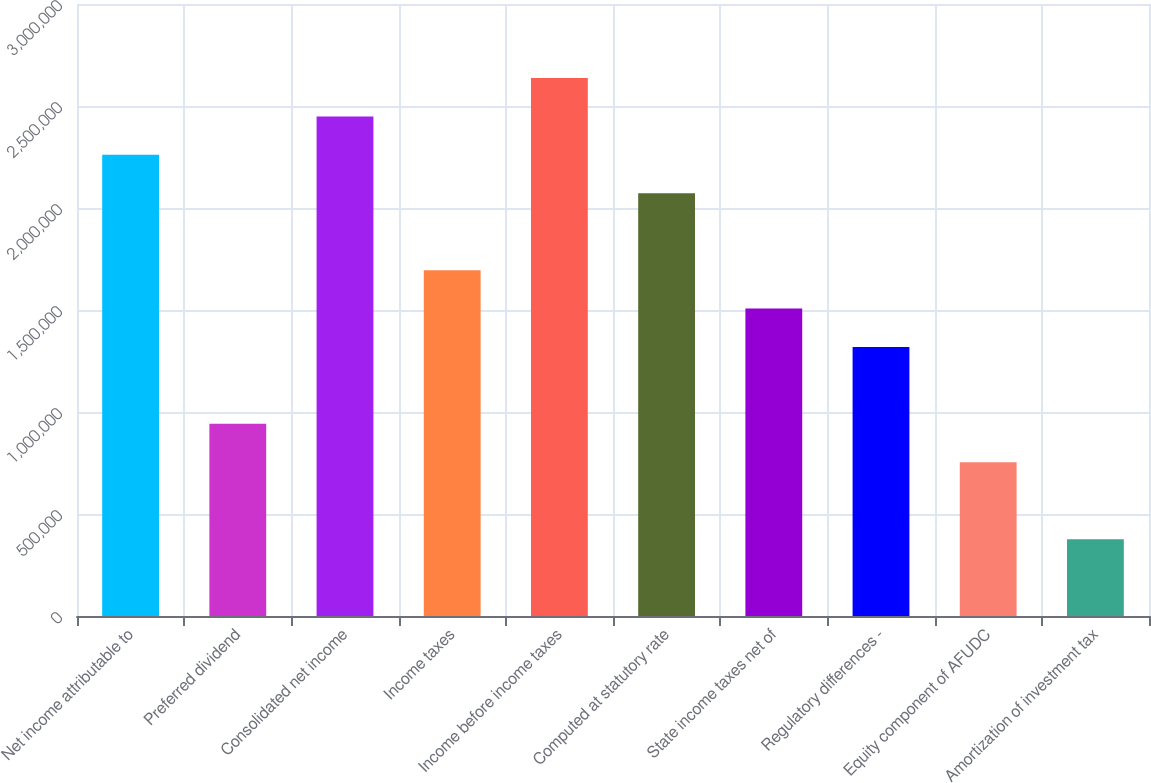Convert chart. <chart><loc_0><loc_0><loc_500><loc_500><bar_chart><fcel>Net income attributable to<fcel>Preferred dividend<fcel>Consolidated net income<fcel>Income taxes<fcel>Income before income taxes<fcel>Computed at statutory rate<fcel>State income taxes net of<fcel>Regulatory differences -<fcel>Equity component of AFUDC<fcel>Amortization of investment tax<nl><fcel>2.26054e+06<fcel>941912<fcel>2.44892e+06<fcel>1.69541e+06<fcel>2.63729e+06<fcel>2.07217e+06<fcel>1.50704e+06<fcel>1.31866e+06<fcel>753536<fcel>376785<nl></chart> 